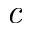Convert formula to latex. <formula><loc_0><loc_0><loc_500><loc_500>c</formula> 